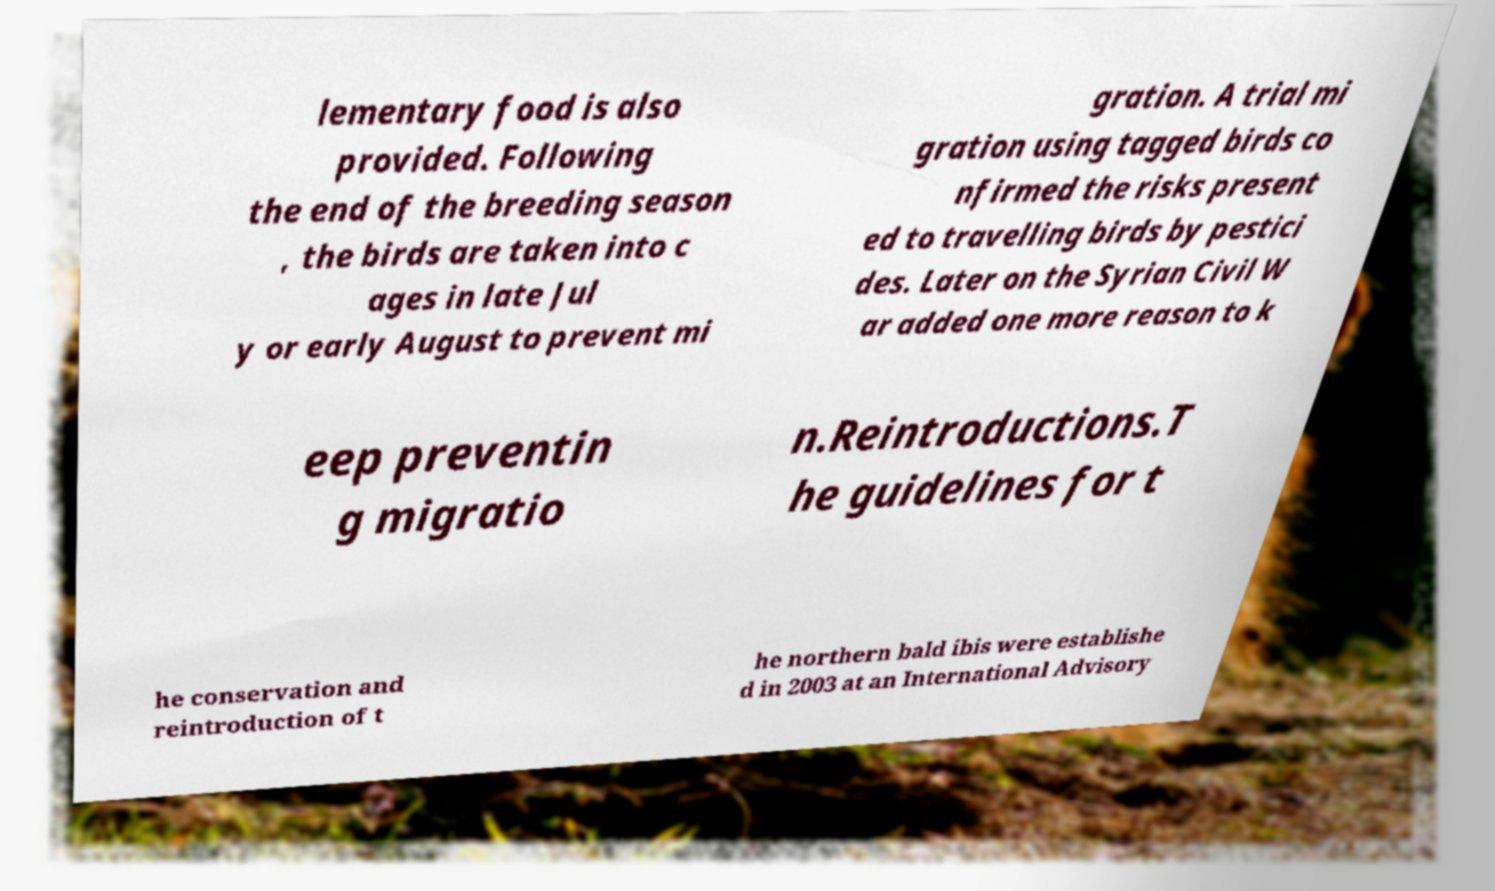Can you accurately transcribe the text from the provided image for me? lementary food is also provided. Following the end of the breeding season , the birds are taken into c ages in late Jul y or early August to prevent mi gration. A trial mi gration using tagged birds co nfirmed the risks present ed to travelling birds by pestici des. Later on the Syrian Civil W ar added one more reason to k eep preventin g migratio n.Reintroductions.T he guidelines for t he conservation and reintroduction of t he northern bald ibis were establishe d in 2003 at an International Advisory 